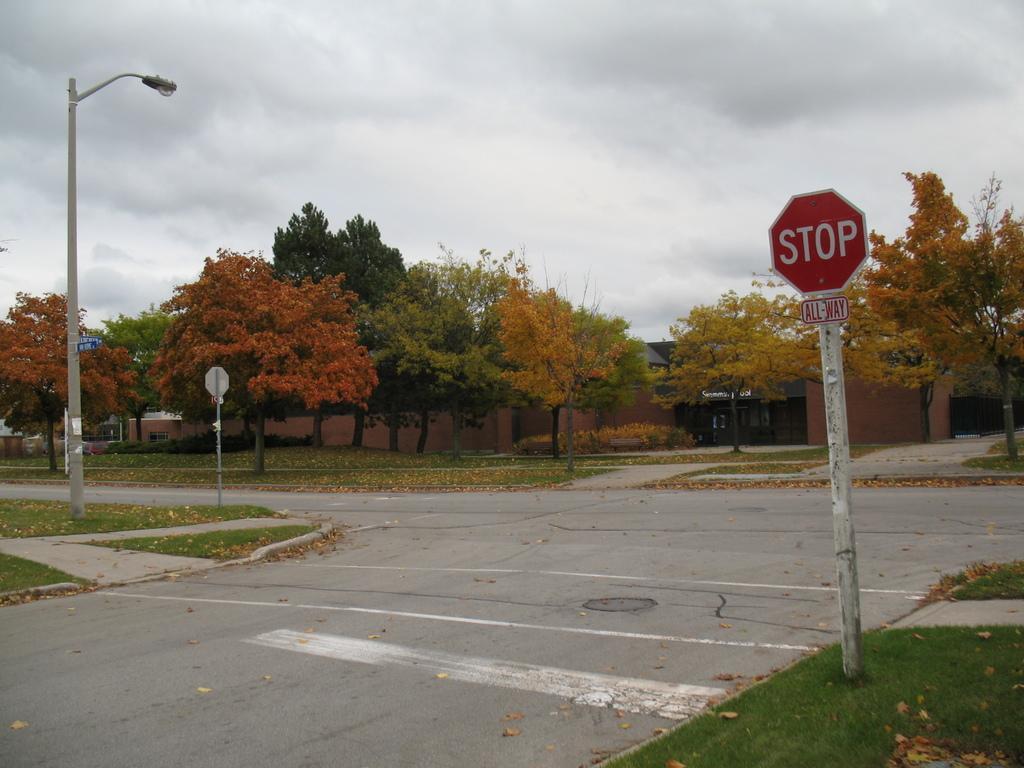Could you give a brief overview of what you see in this image? In this image, I can see a road, trees, buildings, grass and boards to the poles. On the left side of the image, there is a street light. In the background, there is the sky. 